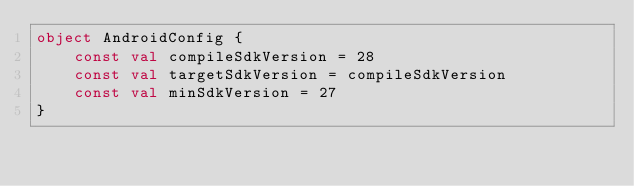<code> <loc_0><loc_0><loc_500><loc_500><_Kotlin_>object AndroidConfig {
    const val compileSdkVersion = 28
    const val targetSdkVersion = compileSdkVersion
    const val minSdkVersion = 27
}</code> 